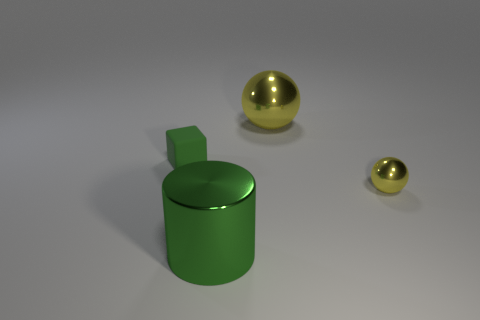Is there any other thing that is made of the same material as the cube?
Ensure brevity in your answer.  No. Are there any large spheres?
Provide a succinct answer. Yes. There is a small thing that is on the right side of the big cylinder; does it have the same shape as the big thing to the left of the big yellow sphere?
Provide a succinct answer. No. Are there any cylinders made of the same material as the tiny green block?
Provide a short and direct response. No. Does the yellow object that is in front of the tiny matte object have the same material as the big yellow object?
Provide a succinct answer. Yes. Are there more big metallic cylinders behind the tiny yellow shiny sphere than green matte objects that are right of the block?
Your answer should be very brief. No. There is a thing that is the same size as the rubber cube; what color is it?
Your response must be concise. Yellow. Are there any big metallic cylinders that have the same color as the big ball?
Offer a terse response. No. There is a small thing behind the small shiny ball; does it have the same color as the large shiny object in front of the tiny yellow thing?
Provide a succinct answer. Yes. What is the yellow ball that is behind the matte thing made of?
Offer a very short reply. Metal. 